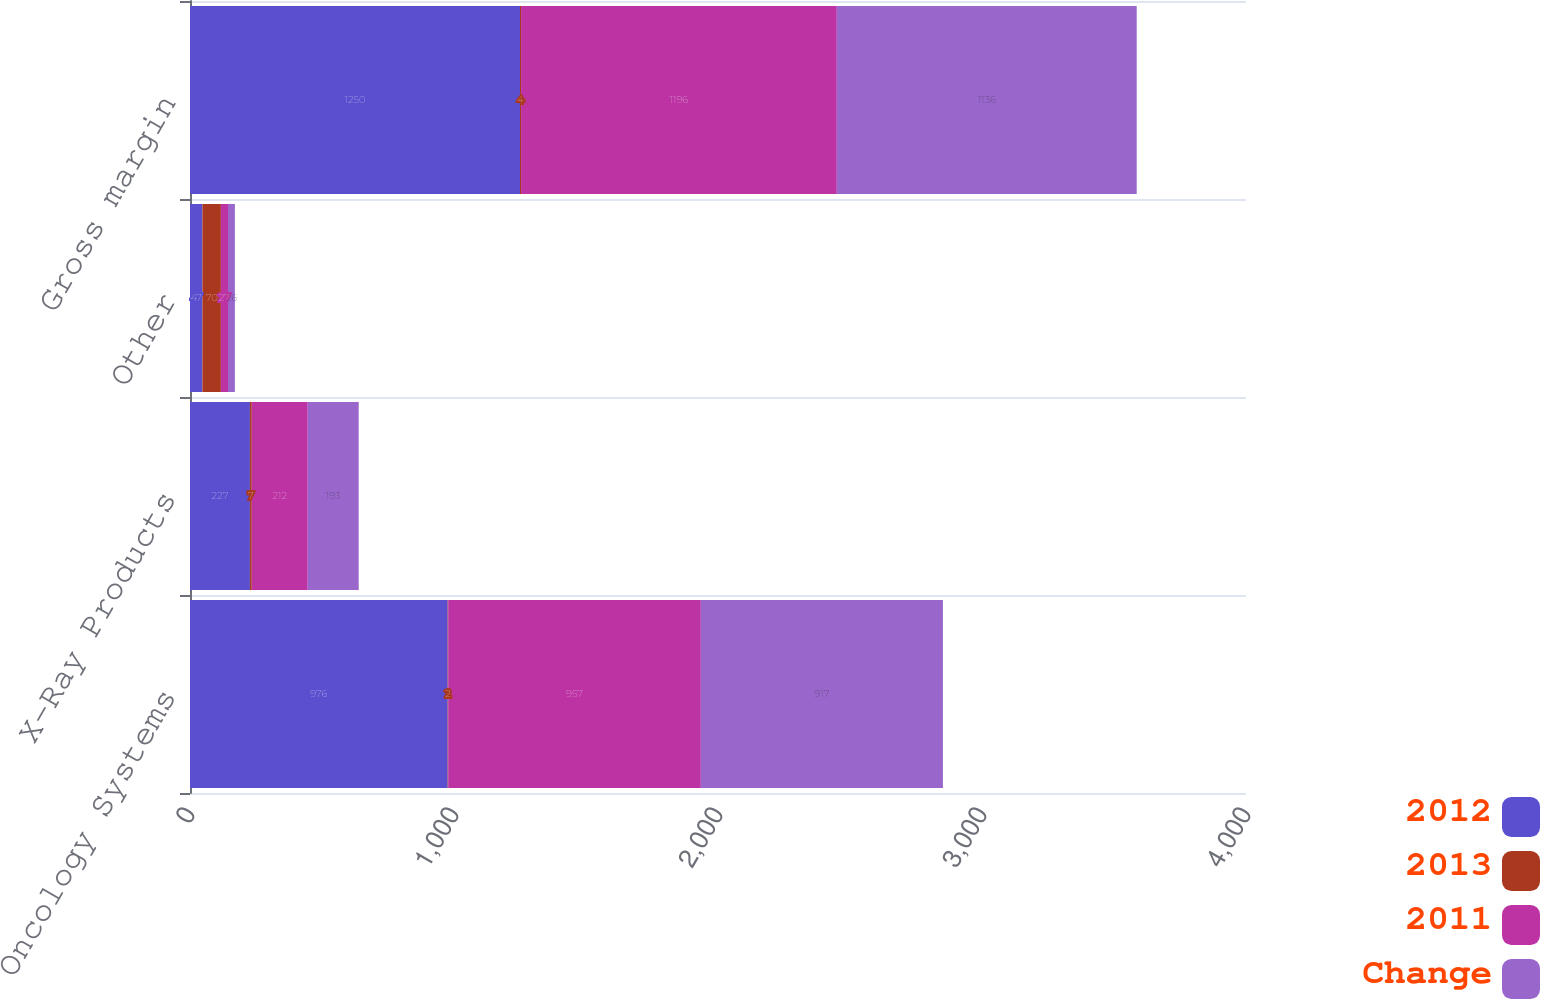Convert chart. <chart><loc_0><loc_0><loc_500><loc_500><stacked_bar_chart><ecel><fcel>Oncology Systems<fcel>X-Ray Products<fcel>Other<fcel>Gross margin<nl><fcel>2012<fcel>976<fcel>227<fcel>47<fcel>1250<nl><fcel>2013<fcel>2<fcel>7<fcel>70<fcel>4<nl><fcel>2011<fcel>957<fcel>212<fcel>27<fcel>1196<nl><fcel>Change<fcel>917<fcel>193<fcel>26<fcel>1136<nl></chart> 